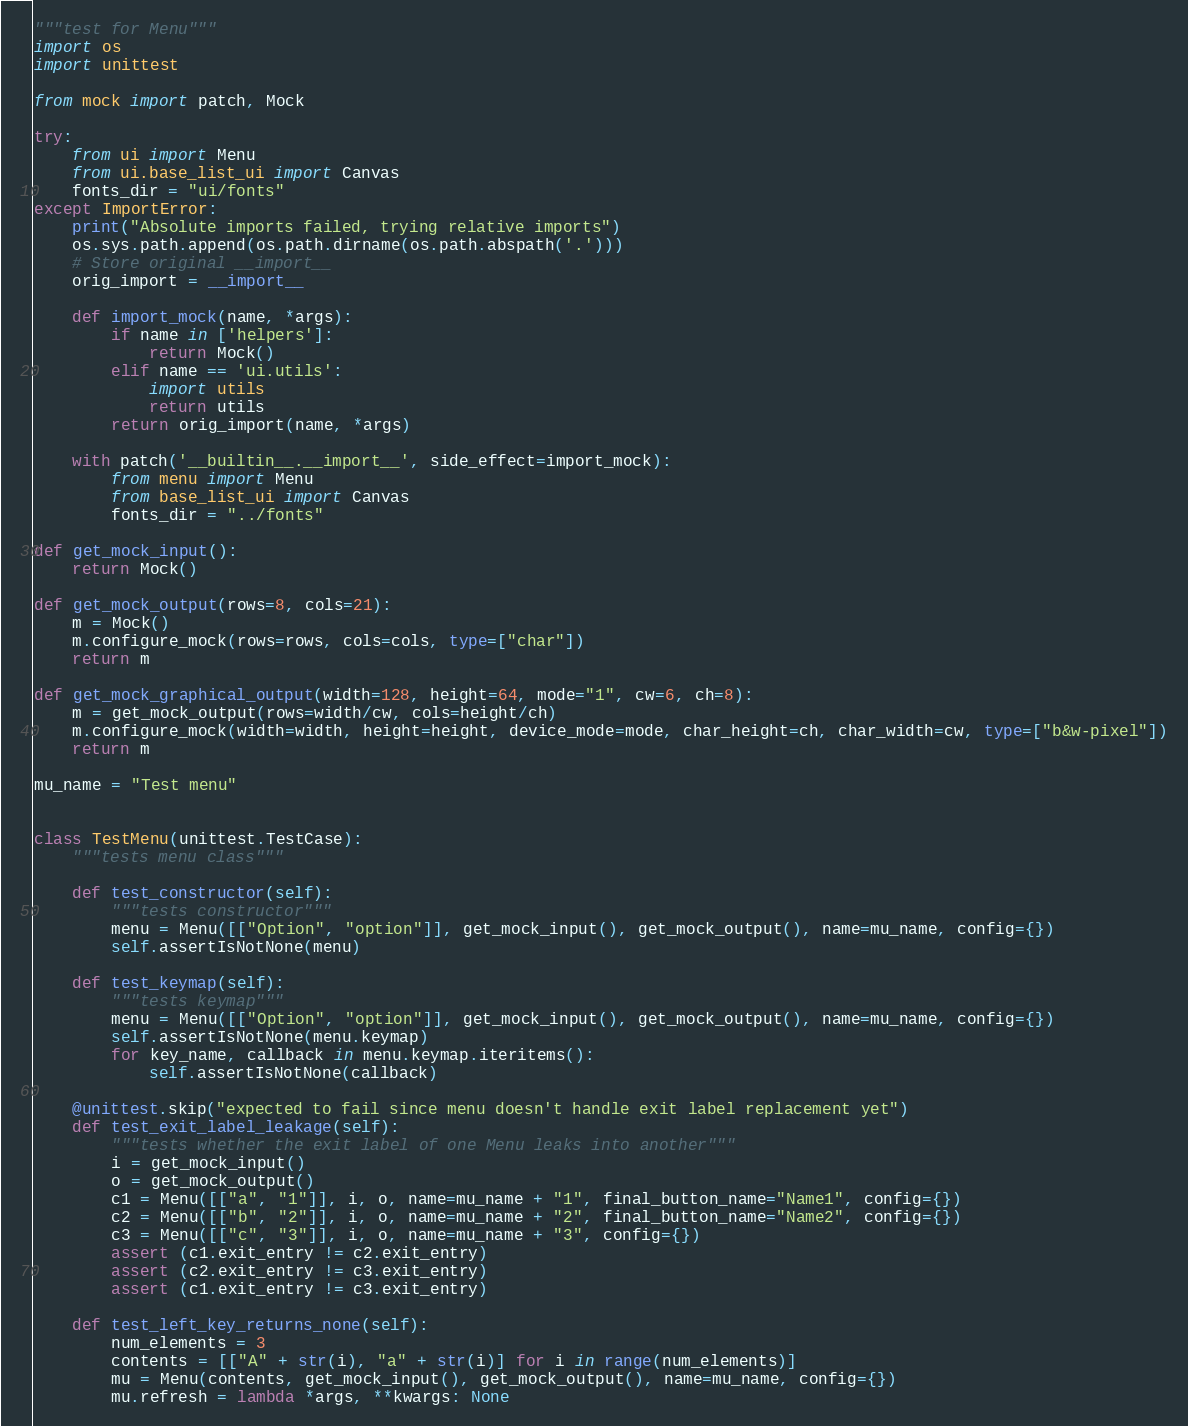<code> <loc_0><loc_0><loc_500><loc_500><_Python_>"""test for Menu"""
import os
import unittest

from mock import patch, Mock

try:
    from ui import Menu
    from ui.base_list_ui import Canvas
    fonts_dir = "ui/fonts"
except ImportError:
    print("Absolute imports failed, trying relative imports")
    os.sys.path.append(os.path.dirname(os.path.abspath('.')))
    # Store original __import__
    orig_import = __import__

    def import_mock(name, *args):
        if name in ['helpers']:
            return Mock()
        elif name == 'ui.utils':
            import utils
            return utils
        return orig_import(name, *args)

    with patch('__builtin__.__import__', side_effect=import_mock):
        from menu import Menu
        from base_list_ui import Canvas
        fonts_dir = "../fonts"

def get_mock_input():
    return Mock()

def get_mock_output(rows=8, cols=21):
    m = Mock()
    m.configure_mock(rows=rows, cols=cols, type=["char"])
    return m

def get_mock_graphical_output(width=128, height=64, mode="1", cw=6, ch=8):
    m = get_mock_output(rows=width/cw, cols=height/ch)
    m.configure_mock(width=width, height=height, device_mode=mode, char_height=ch, char_width=cw, type=["b&w-pixel"])
    return m

mu_name = "Test menu"


class TestMenu(unittest.TestCase):
    """tests menu class"""

    def test_constructor(self):
        """tests constructor"""
        menu = Menu([["Option", "option"]], get_mock_input(), get_mock_output(), name=mu_name, config={})
        self.assertIsNotNone(menu)

    def test_keymap(self):
        """tests keymap"""
        menu = Menu([["Option", "option"]], get_mock_input(), get_mock_output(), name=mu_name, config={})
        self.assertIsNotNone(menu.keymap)
        for key_name, callback in menu.keymap.iteritems():
            self.assertIsNotNone(callback)

    @unittest.skip("expected to fail since menu doesn't handle exit label replacement yet")
    def test_exit_label_leakage(self):
        """tests whether the exit label of one Menu leaks into another"""
        i = get_mock_input()
        o = get_mock_output()
        c1 = Menu([["a", "1"]], i, o, name=mu_name + "1", final_button_name="Name1", config={})
        c2 = Menu([["b", "2"]], i, o, name=mu_name + "2", final_button_name="Name2", config={})
        c3 = Menu([["c", "3"]], i, o, name=mu_name + "3", config={})
        assert (c1.exit_entry != c2.exit_entry)
        assert (c2.exit_entry != c3.exit_entry)
        assert (c1.exit_entry != c3.exit_entry)

    def test_left_key_returns_none(self):
        num_elements = 3
        contents = [["A" + str(i), "a" + str(i)] for i in range(num_elements)]
        mu = Menu(contents, get_mock_input(), get_mock_output(), name=mu_name, config={})
        mu.refresh = lambda *args, **kwargs: None
</code> 